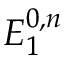Convert formula to latex. <formula><loc_0><loc_0><loc_500><loc_500>E _ { 1 } ^ { 0 , n }</formula> 